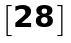Convert formula to latex. <formula><loc_0><loc_0><loc_500><loc_500>\begin{bmatrix} 2 8 \end{bmatrix}</formula> 